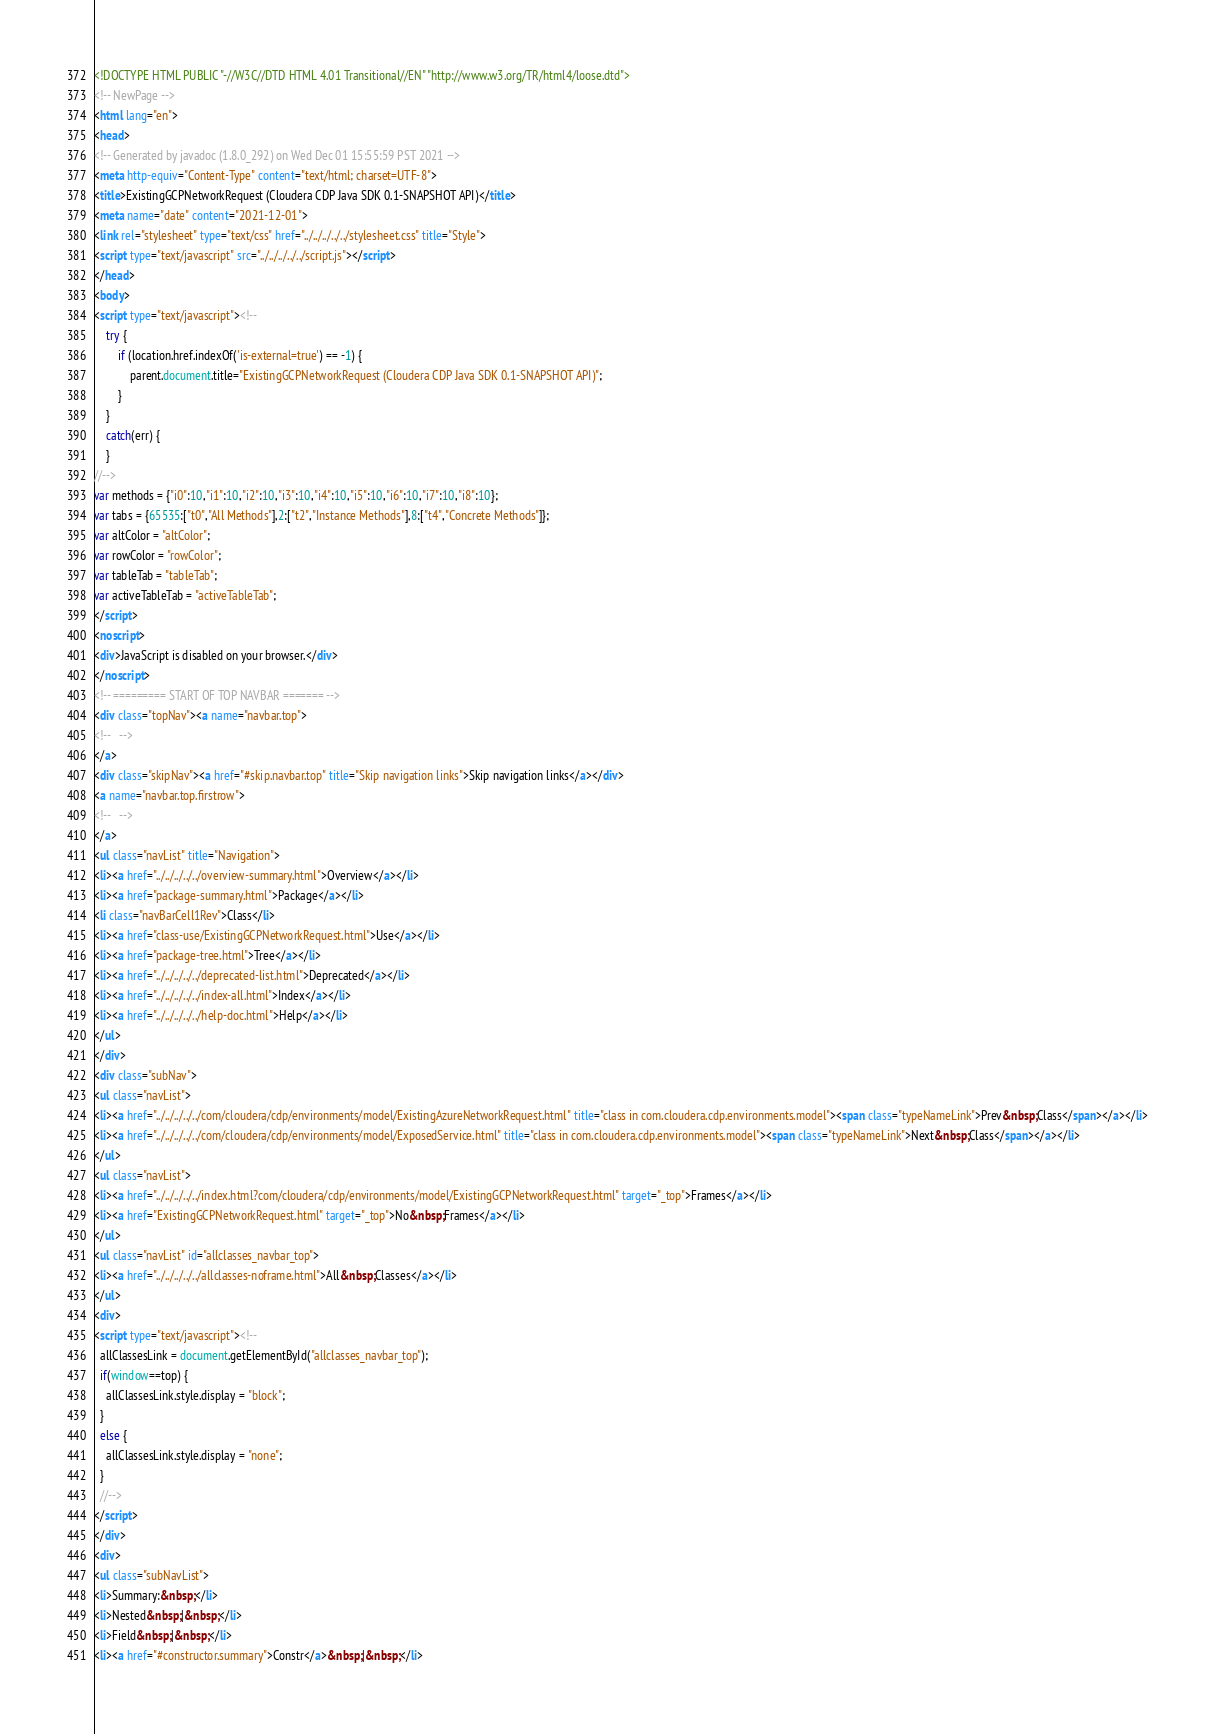Convert code to text. <code><loc_0><loc_0><loc_500><loc_500><_HTML_><!DOCTYPE HTML PUBLIC "-//W3C//DTD HTML 4.01 Transitional//EN" "http://www.w3.org/TR/html4/loose.dtd">
<!-- NewPage -->
<html lang="en">
<head>
<!-- Generated by javadoc (1.8.0_292) on Wed Dec 01 15:55:59 PST 2021 -->
<meta http-equiv="Content-Type" content="text/html; charset=UTF-8">
<title>ExistingGCPNetworkRequest (Cloudera CDP Java SDK 0.1-SNAPSHOT API)</title>
<meta name="date" content="2021-12-01">
<link rel="stylesheet" type="text/css" href="../../../../../stylesheet.css" title="Style">
<script type="text/javascript" src="../../../../../script.js"></script>
</head>
<body>
<script type="text/javascript"><!--
    try {
        if (location.href.indexOf('is-external=true') == -1) {
            parent.document.title="ExistingGCPNetworkRequest (Cloudera CDP Java SDK 0.1-SNAPSHOT API)";
        }
    }
    catch(err) {
    }
//-->
var methods = {"i0":10,"i1":10,"i2":10,"i3":10,"i4":10,"i5":10,"i6":10,"i7":10,"i8":10};
var tabs = {65535:["t0","All Methods"],2:["t2","Instance Methods"],8:["t4","Concrete Methods"]};
var altColor = "altColor";
var rowColor = "rowColor";
var tableTab = "tableTab";
var activeTableTab = "activeTableTab";
</script>
<noscript>
<div>JavaScript is disabled on your browser.</div>
</noscript>
<!-- ========= START OF TOP NAVBAR ======= -->
<div class="topNav"><a name="navbar.top">
<!--   -->
</a>
<div class="skipNav"><a href="#skip.navbar.top" title="Skip navigation links">Skip navigation links</a></div>
<a name="navbar.top.firstrow">
<!--   -->
</a>
<ul class="navList" title="Navigation">
<li><a href="../../../../../overview-summary.html">Overview</a></li>
<li><a href="package-summary.html">Package</a></li>
<li class="navBarCell1Rev">Class</li>
<li><a href="class-use/ExistingGCPNetworkRequest.html">Use</a></li>
<li><a href="package-tree.html">Tree</a></li>
<li><a href="../../../../../deprecated-list.html">Deprecated</a></li>
<li><a href="../../../../../index-all.html">Index</a></li>
<li><a href="../../../../../help-doc.html">Help</a></li>
</ul>
</div>
<div class="subNav">
<ul class="navList">
<li><a href="../../../../../com/cloudera/cdp/environments/model/ExistingAzureNetworkRequest.html" title="class in com.cloudera.cdp.environments.model"><span class="typeNameLink">Prev&nbsp;Class</span></a></li>
<li><a href="../../../../../com/cloudera/cdp/environments/model/ExposedService.html" title="class in com.cloudera.cdp.environments.model"><span class="typeNameLink">Next&nbsp;Class</span></a></li>
</ul>
<ul class="navList">
<li><a href="../../../../../index.html?com/cloudera/cdp/environments/model/ExistingGCPNetworkRequest.html" target="_top">Frames</a></li>
<li><a href="ExistingGCPNetworkRequest.html" target="_top">No&nbsp;Frames</a></li>
</ul>
<ul class="navList" id="allclasses_navbar_top">
<li><a href="../../../../../allclasses-noframe.html">All&nbsp;Classes</a></li>
</ul>
<div>
<script type="text/javascript"><!--
  allClassesLink = document.getElementById("allclasses_navbar_top");
  if(window==top) {
    allClassesLink.style.display = "block";
  }
  else {
    allClassesLink.style.display = "none";
  }
  //-->
</script>
</div>
<div>
<ul class="subNavList">
<li>Summary:&nbsp;</li>
<li>Nested&nbsp;|&nbsp;</li>
<li>Field&nbsp;|&nbsp;</li>
<li><a href="#constructor.summary">Constr</a>&nbsp;|&nbsp;</li></code> 